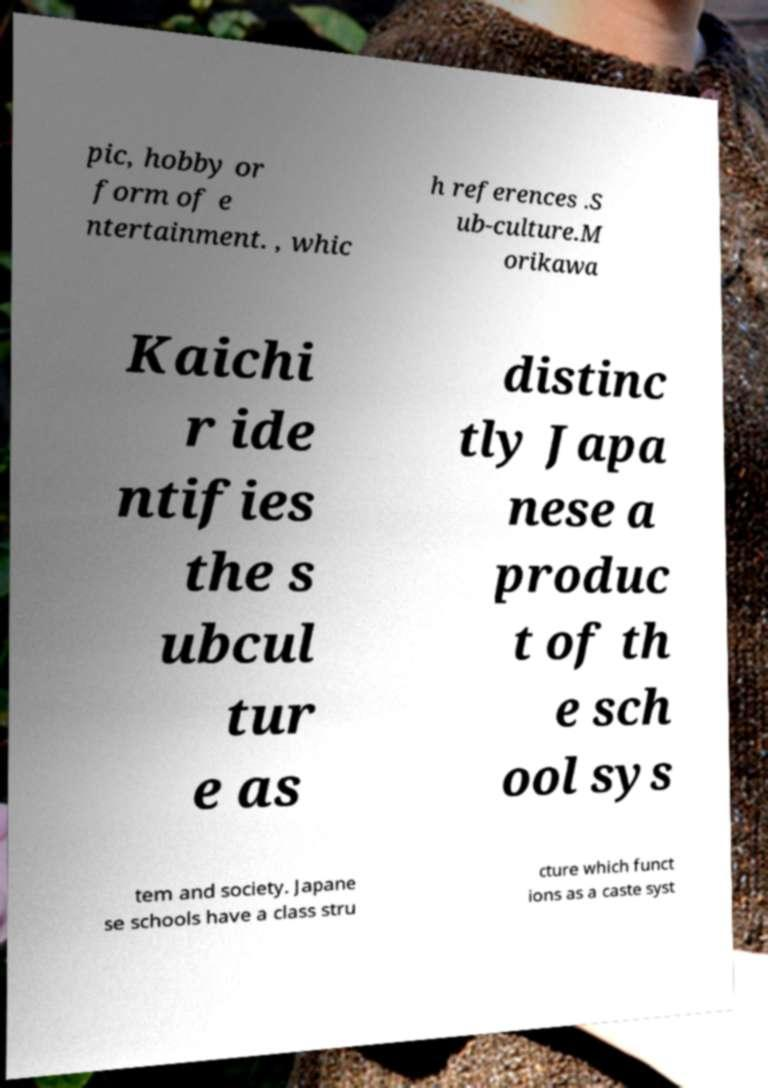What messages or text are displayed in this image? I need them in a readable, typed format. pic, hobby or form of e ntertainment. , whic h references .S ub-culture.M orikawa Kaichi r ide ntifies the s ubcul tur e as distinc tly Japa nese a produc t of th e sch ool sys tem and society. Japane se schools have a class stru cture which funct ions as a caste syst 